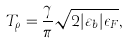<formula> <loc_0><loc_0><loc_500><loc_500>T _ { \rho } = \frac { \gamma } { \pi } \sqrt { 2 | \varepsilon _ { b } | \epsilon _ { F } } ,</formula> 